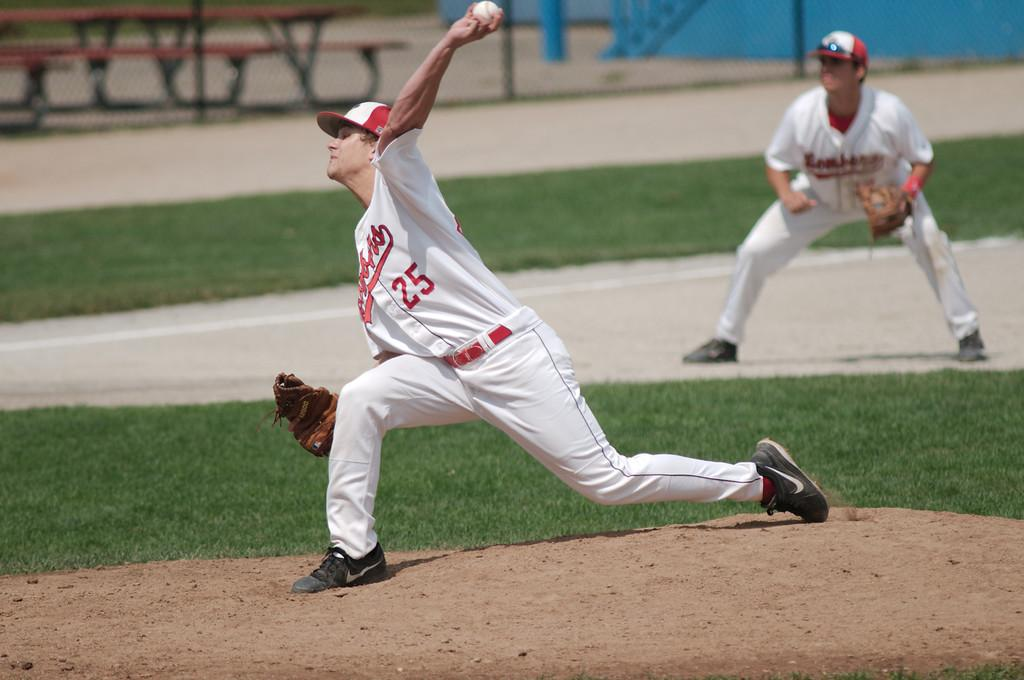<image>
Relay a brief, clear account of the picture shown. A man with a baseball uniform with the number 25 on it is in the process of throwing a ball. 